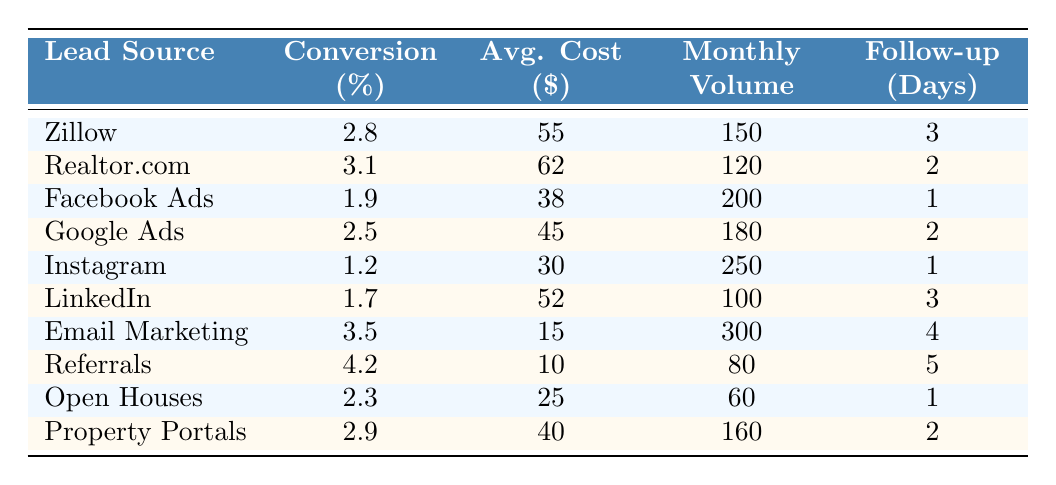What is the conversion percentage for Email Marketing? Referring to the table, the "Conversion (%)" value for Email Marketing is listed as 3.5.
Answer: 3.5 Which lead source has the highest conversion percentage? By examining the "Conversion (%)" column, Referrals has the highest value at 4.2.
Answer: Referrals What is the average cost of leads from Zillow and Realtor.com? To find the average cost, add the average costs of both sources: 55 (Zillow) + 62 (Realtor.com) = 117, then divide by 2, so 117/2 = 58.5.
Answer: 58.5 How many days of follow-up are required for the lead sources with the lowest conversion percentages? The lead sources with the lowest conversion percentages are Facebook Ads (1.9%) and Instagram (1.2%). Their follow-up days are 1 and 1 respectively, so the lowest is 1 day.
Answer: 1 Is the average lead cost for Referrals higher than for Property Portals? The average lead cost for Referrals is 10, while Property Portals has a cost of 40. Since 10 is less than 40, the statement is false.
Answer: No What is the total monthly lead volume for all sources? To calculate the total, sum all the monthly volumes: 150 + 120 + 200 + 180 + 250 + 100 + 300 + 80 + 60 + 160 = 1640.
Answer: 1640 Which lead source requires the longest follow-up days, and how many days is it? Looking at the "Follow-up (Days)" column, Referrals has the highest value at 5 days.
Answer: Referrals, 5 days What is the conversion percentage difference between Email Marketing and Instagram? The conversion percentage for Email Marketing is 3.5 and for Instagram is 1.2. The difference is 3.5 - 1.2 = 2.3.
Answer: 2.3 What is the average lead cost across all sources? To find the average lead cost, add all lead costs: (55 + 62 + 38 + 45 + 30 + 52 + 15 + 10 + 25 + 40) = 372, then divide by 10 for the average, which is 37.2.
Answer: 37.2 Which lead source has the highest monthly lead volume, and what is that volume? Upon checking the "Monthly Volume" column, Email Marketing has the highest volume at 300 leads.
Answer: Email Marketing, 300 